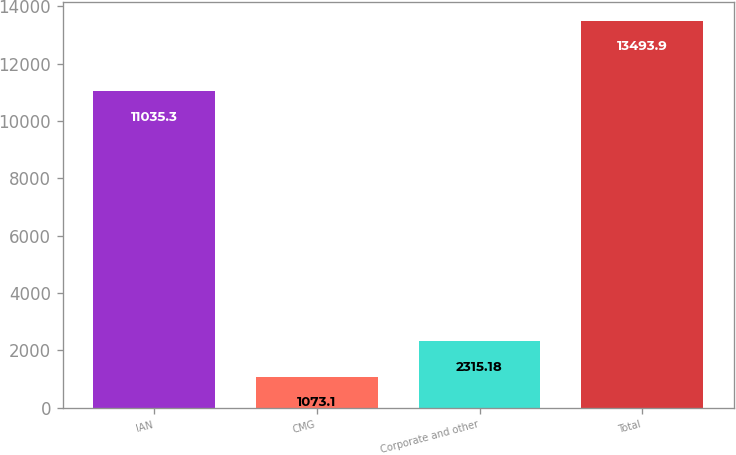Convert chart to OTSL. <chart><loc_0><loc_0><loc_500><loc_500><bar_chart><fcel>IAN<fcel>CMG<fcel>Corporate and other<fcel>Total<nl><fcel>11035.3<fcel>1073.1<fcel>2315.18<fcel>13493.9<nl></chart> 